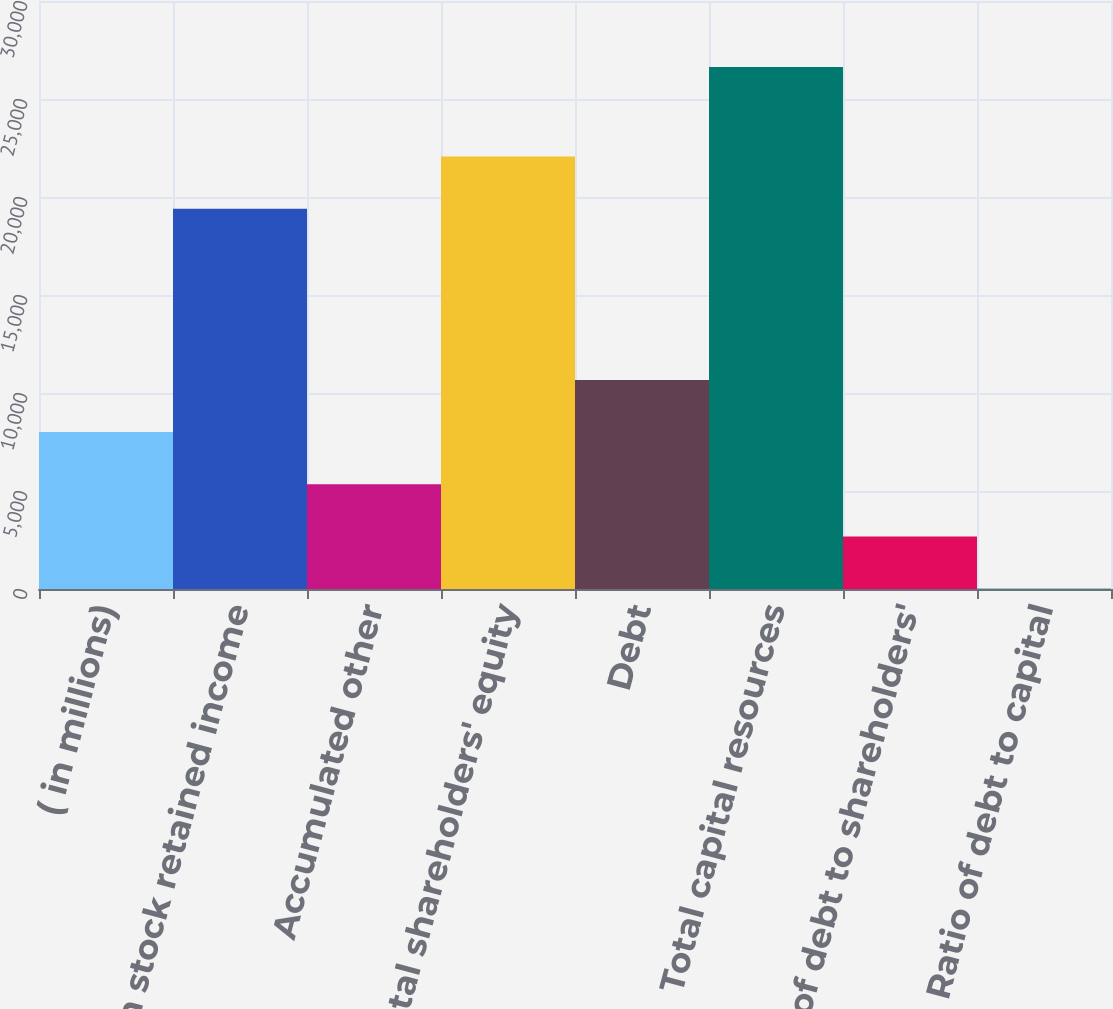<chart> <loc_0><loc_0><loc_500><loc_500><bar_chart><fcel>( in millions)<fcel>Common stock retained income<fcel>Accumulated other<fcel>Total shareholders' equity<fcel>Debt<fcel>Total capital resources<fcel>Ratio of debt to shareholders'<fcel>Ratio of debt to capital<nl><fcel>8006.99<fcel>19405<fcel>5345.56<fcel>22066.4<fcel>10668.4<fcel>26637<fcel>2684.13<fcel>22.7<nl></chart> 